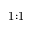Convert formula to latex. <formula><loc_0><loc_0><loc_500><loc_500>1 { \colon } 1</formula> 